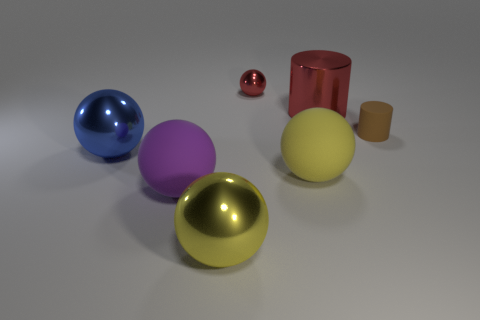What is the color of the tiny metal thing?
Offer a very short reply. Red. What number of objects are either red things that are in front of the small red metallic ball or yellow balls?
Provide a short and direct response. 3. Is the size of the metallic object right of the red sphere the same as the shiny ball that is in front of the large purple object?
Your answer should be very brief. Yes. Is there anything else that is the same material as the big purple ball?
Ensure brevity in your answer.  Yes. How many objects are cylinders that are behind the tiny rubber object or things that are behind the purple rubber thing?
Make the answer very short. 5. Does the brown cylinder have the same material as the large yellow ball to the right of the tiny sphere?
Your response must be concise. Yes. There is a thing that is in front of the metallic cylinder and on the right side of the big yellow matte object; what is its shape?
Your response must be concise. Cylinder. What number of other objects are there of the same color as the tiny shiny sphere?
Make the answer very short. 1. What is the shape of the large yellow metallic thing?
Make the answer very short. Sphere. There is a rubber object that is in front of the yellow sphere that is on the right side of the small red thing; what is its color?
Your answer should be compact. Purple. 